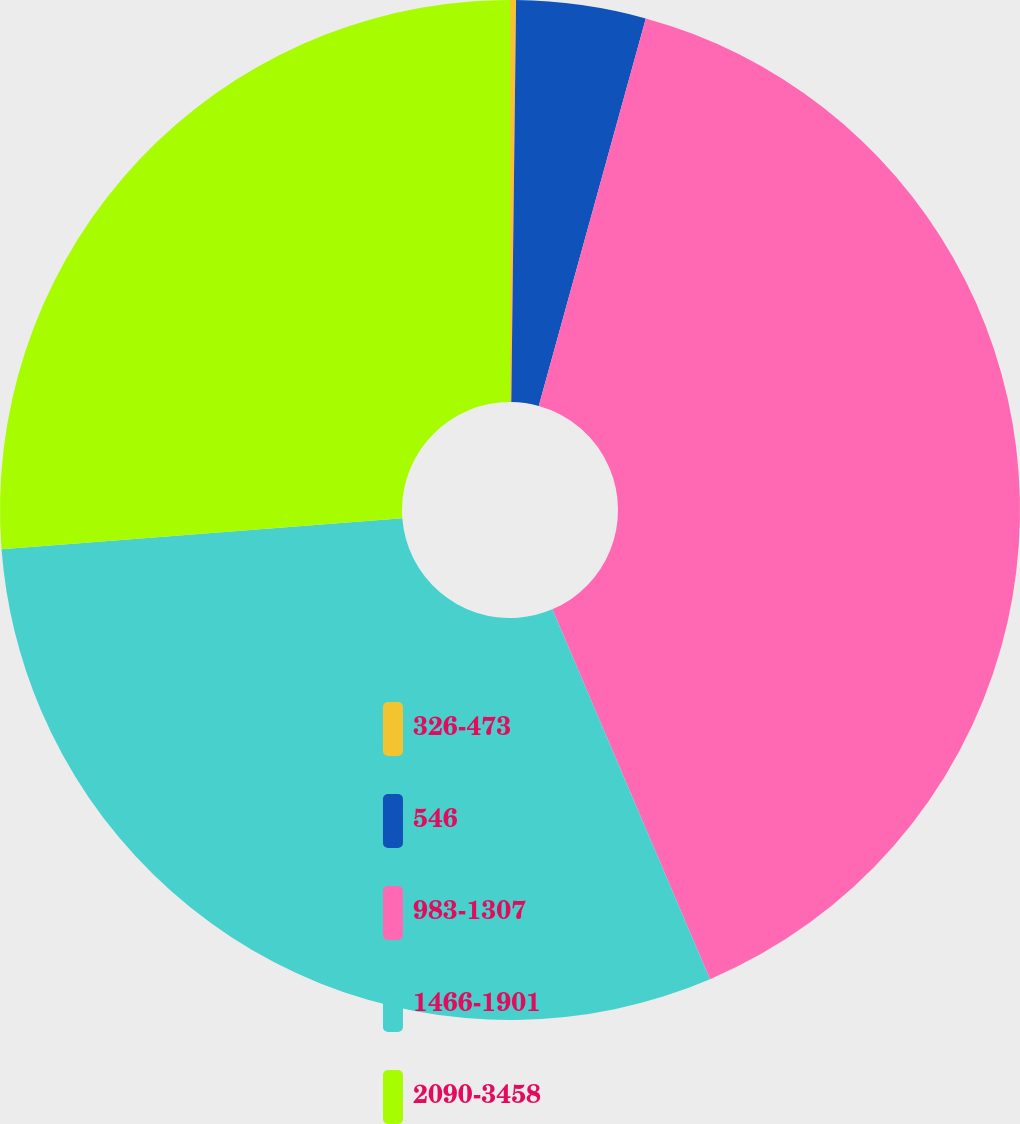Convert chart to OTSL. <chart><loc_0><loc_0><loc_500><loc_500><pie_chart><fcel>326-473<fcel>546<fcel>983-1307<fcel>1466-1901<fcel>2090-3458<nl><fcel>0.19%<fcel>4.1%<fcel>39.3%<fcel>30.19%<fcel>26.23%<nl></chart> 